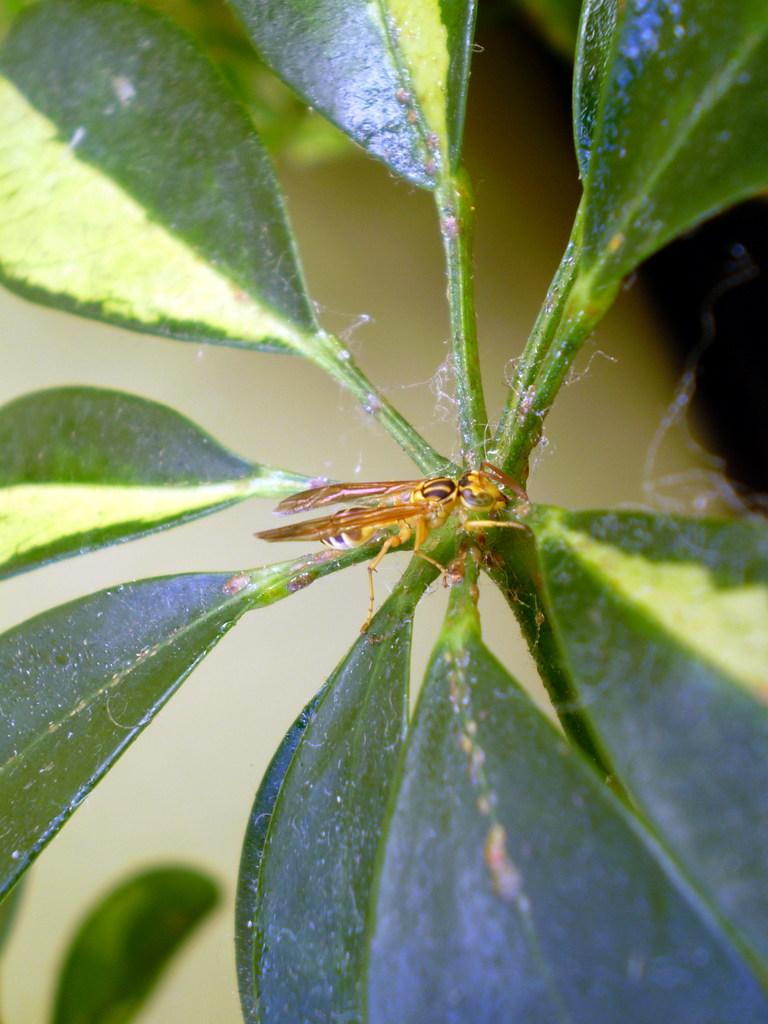What type of plant is visible in the image? There are green leaves on a plant in the image. What type of pickle is being observed in the image? There is no pickle present in the image; it features a plant with green leaves. What is the plant's mindset in the image? Plants do not have minds or mindsets, so this question cannot be answered. 